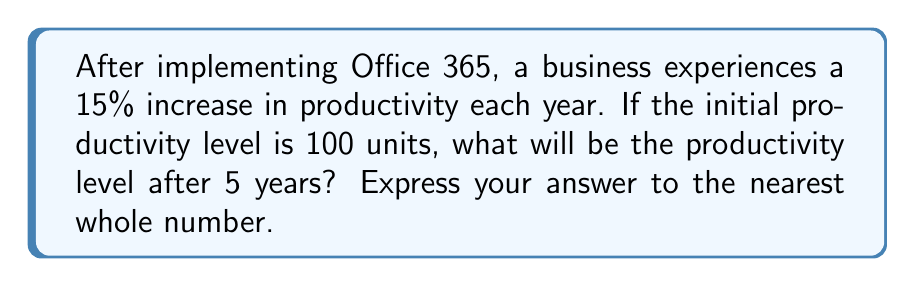Can you answer this question? Let's approach this step-by-step:

1) The initial productivity is 100 units.
2) Each year, the productivity increases by 15% or 1.15 times.
3) We need to calculate this for 5 years.

This scenario represents exponential growth, which can be modeled by the equation:

$$ A = P(1 + r)^t $$

Where:
A = Final amount
P = Initial principal balance
r = Annual growth rate (in decimal form)
t = Number of years

In this case:
P = 100 (initial productivity)
r = 0.15 (15% expressed as a decimal)
t = 5 years

Let's plug these values into our equation:

$$ A = 100(1 + 0.15)^5 $$
$$ A = 100(1.15)^5 $$

Now, let's calculate:

$$ A = 100 * 2.0113689 $$
$$ A = 201.13689 $$

Rounding to the nearest whole number:

$$ A ≈ 201 $$
Answer: 201 units 